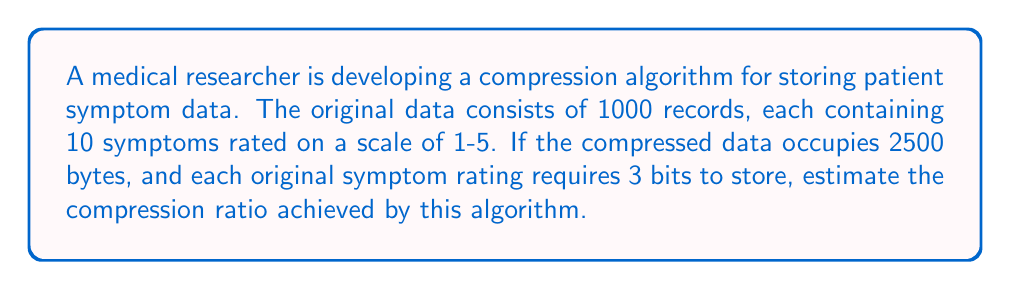Help me with this question. To solve this problem, we'll follow these steps:

1. Calculate the size of the original data:
   - Each symptom rating requires 3 bits
   - There are 10 symptoms per record
   - There are 1000 records
   
   Original size = $1000 \times 10 \times 3$ bits
                 = $30,000$ bits
                 = $30,000 \div 8$ bytes (since 8 bits = 1 byte)
                 = $3,750$ bytes

2. Note the size of the compressed data:
   Compressed size = 2500 bytes

3. Calculate the compression ratio:
   Compression ratio = $\frac{\text{Original size}}{\text{Compressed size}}$
                     = $\frac{3,750}{2,500}$
                     = $1.5$

4. Express the ratio as a percentage:
   Compression percentage = $(1 - \frac{1}{\text{Compression ratio}}) \times 100\%$
                          = $(1 - \frac{1}{1.5}) \times 100\%$
                          = $(1 - 0.6667) \times 100\%$
                          = $0.3333 \times 100\%$
                          = $33.33\%$

This means the compressed data takes up 66.67% less space than the original data.
Answer: The compression ratio is 1.5:1, or a 33.33% reduction in data size. 